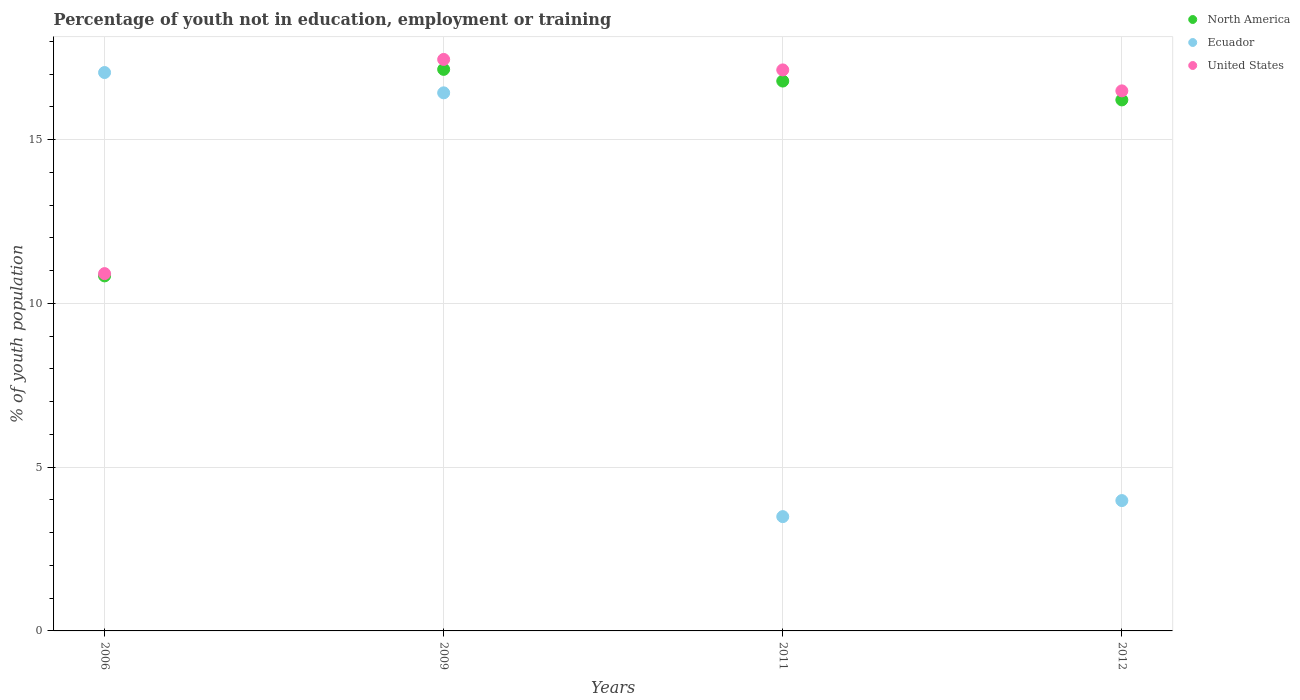Is the number of dotlines equal to the number of legend labels?
Your response must be concise. Yes. What is the percentage of unemployed youth population in in Ecuador in 2011?
Ensure brevity in your answer.  3.49. Across all years, what is the maximum percentage of unemployed youth population in in Ecuador?
Your answer should be compact. 17.05. Across all years, what is the minimum percentage of unemployed youth population in in Ecuador?
Keep it short and to the point. 3.49. In which year was the percentage of unemployed youth population in in Ecuador maximum?
Make the answer very short. 2006. What is the total percentage of unemployed youth population in in North America in the graph?
Provide a succinct answer. 60.99. What is the difference between the percentage of unemployed youth population in in North America in 2011 and that in 2012?
Provide a short and direct response. 0.58. What is the difference between the percentage of unemployed youth population in in United States in 2011 and the percentage of unemployed youth population in in North America in 2012?
Offer a terse response. 0.92. What is the average percentage of unemployed youth population in in Ecuador per year?
Provide a succinct answer. 10.24. In the year 2009, what is the difference between the percentage of unemployed youth population in in Ecuador and percentage of unemployed youth population in in United States?
Your response must be concise. -1.02. In how many years, is the percentage of unemployed youth population in in United States greater than 16 %?
Provide a succinct answer. 3. What is the ratio of the percentage of unemployed youth population in in United States in 2006 to that in 2009?
Your response must be concise. 0.63. Is the percentage of unemployed youth population in in Ecuador in 2006 less than that in 2009?
Your answer should be compact. No. What is the difference between the highest and the second highest percentage of unemployed youth population in in United States?
Provide a short and direct response. 0.32. What is the difference between the highest and the lowest percentage of unemployed youth population in in North America?
Give a very brief answer. 6.31. Is the sum of the percentage of unemployed youth population in in United States in 2009 and 2012 greater than the maximum percentage of unemployed youth population in in North America across all years?
Make the answer very short. Yes. Is it the case that in every year, the sum of the percentage of unemployed youth population in in North America and percentage of unemployed youth population in in United States  is greater than the percentage of unemployed youth population in in Ecuador?
Ensure brevity in your answer.  Yes. Does the percentage of unemployed youth population in in United States monotonically increase over the years?
Provide a short and direct response. No. Is the percentage of unemployed youth population in in United States strictly greater than the percentage of unemployed youth population in in Ecuador over the years?
Ensure brevity in your answer.  No. Is the percentage of unemployed youth population in in Ecuador strictly less than the percentage of unemployed youth population in in United States over the years?
Give a very brief answer. No. How many years are there in the graph?
Your answer should be compact. 4. What is the difference between two consecutive major ticks on the Y-axis?
Offer a very short reply. 5. Does the graph contain grids?
Give a very brief answer. Yes. Where does the legend appear in the graph?
Offer a very short reply. Top right. How many legend labels are there?
Make the answer very short. 3. How are the legend labels stacked?
Make the answer very short. Vertical. What is the title of the graph?
Your answer should be compact. Percentage of youth not in education, employment or training. Does "Luxembourg" appear as one of the legend labels in the graph?
Give a very brief answer. No. What is the label or title of the X-axis?
Offer a very short reply. Years. What is the label or title of the Y-axis?
Make the answer very short. % of youth population. What is the % of youth population in North America in 2006?
Provide a short and direct response. 10.84. What is the % of youth population of Ecuador in 2006?
Keep it short and to the point. 17.05. What is the % of youth population of United States in 2006?
Provide a short and direct response. 10.91. What is the % of youth population in North America in 2009?
Your answer should be very brief. 17.15. What is the % of youth population of Ecuador in 2009?
Your answer should be compact. 16.43. What is the % of youth population of United States in 2009?
Your answer should be very brief. 17.45. What is the % of youth population of North America in 2011?
Offer a very short reply. 16.79. What is the % of youth population of Ecuador in 2011?
Give a very brief answer. 3.49. What is the % of youth population in United States in 2011?
Give a very brief answer. 17.13. What is the % of youth population of North America in 2012?
Ensure brevity in your answer.  16.21. What is the % of youth population in Ecuador in 2012?
Provide a short and direct response. 3.98. What is the % of youth population of United States in 2012?
Your response must be concise. 16.49. Across all years, what is the maximum % of youth population of North America?
Your answer should be very brief. 17.15. Across all years, what is the maximum % of youth population in Ecuador?
Provide a succinct answer. 17.05. Across all years, what is the maximum % of youth population in United States?
Make the answer very short. 17.45. Across all years, what is the minimum % of youth population of North America?
Make the answer very short. 10.84. Across all years, what is the minimum % of youth population of Ecuador?
Make the answer very short. 3.49. Across all years, what is the minimum % of youth population of United States?
Give a very brief answer. 10.91. What is the total % of youth population in North America in the graph?
Offer a very short reply. 60.99. What is the total % of youth population of Ecuador in the graph?
Your answer should be very brief. 40.95. What is the total % of youth population in United States in the graph?
Your answer should be very brief. 61.98. What is the difference between the % of youth population in North America in 2006 and that in 2009?
Your response must be concise. -6.31. What is the difference between the % of youth population of Ecuador in 2006 and that in 2009?
Your answer should be very brief. 0.62. What is the difference between the % of youth population in United States in 2006 and that in 2009?
Ensure brevity in your answer.  -6.54. What is the difference between the % of youth population of North America in 2006 and that in 2011?
Your response must be concise. -5.95. What is the difference between the % of youth population in Ecuador in 2006 and that in 2011?
Keep it short and to the point. 13.56. What is the difference between the % of youth population in United States in 2006 and that in 2011?
Ensure brevity in your answer.  -6.22. What is the difference between the % of youth population in North America in 2006 and that in 2012?
Offer a very short reply. -5.37. What is the difference between the % of youth population in Ecuador in 2006 and that in 2012?
Your answer should be compact. 13.07. What is the difference between the % of youth population of United States in 2006 and that in 2012?
Keep it short and to the point. -5.58. What is the difference between the % of youth population in North America in 2009 and that in 2011?
Your answer should be very brief. 0.36. What is the difference between the % of youth population in Ecuador in 2009 and that in 2011?
Keep it short and to the point. 12.94. What is the difference between the % of youth population in United States in 2009 and that in 2011?
Give a very brief answer. 0.32. What is the difference between the % of youth population in North America in 2009 and that in 2012?
Offer a very short reply. 0.93. What is the difference between the % of youth population in Ecuador in 2009 and that in 2012?
Keep it short and to the point. 12.45. What is the difference between the % of youth population of North America in 2011 and that in 2012?
Your answer should be compact. 0.58. What is the difference between the % of youth population of Ecuador in 2011 and that in 2012?
Make the answer very short. -0.49. What is the difference between the % of youth population in United States in 2011 and that in 2012?
Your answer should be compact. 0.64. What is the difference between the % of youth population in North America in 2006 and the % of youth population in Ecuador in 2009?
Offer a very short reply. -5.59. What is the difference between the % of youth population of North America in 2006 and the % of youth population of United States in 2009?
Offer a very short reply. -6.61. What is the difference between the % of youth population of North America in 2006 and the % of youth population of Ecuador in 2011?
Make the answer very short. 7.35. What is the difference between the % of youth population in North America in 2006 and the % of youth population in United States in 2011?
Offer a terse response. -6.29. What is the difference between the % of youth population of Ecuador in 2006 and the % of youth population of United States in 2011?
Offer a terse response. -0.08. What is the difference between the % of youth population in North America in 2006 and the % of youth population in Ecuador in 2012?
Provide a short and direct response. 6.86. What is the difference between the % of youth population in North America in 2006 and the % of youth population in United States in 2012?
Make the answer very short. -5.65. What is the difference between the % of youth population of Ecuador in 2006 and the % of youth population of United States in 2012?
Give a very brief answer. 0.56. What is the difference between the % of youth population in North America in 2009 and the % of youth population in Ecuador in 2011?
Your response must be concise. 13.66. What is the difference between the % of youth population in North America in 2009 and the % of youth population in United States in 2011?
Ensure brevity in your answer.  0.02. What is the difference between the % of youth population in Ecuador in 2009 and the % of youth population in United States in 2011?
Give a very brief answer. -0.7. What is the difference between the % of youth population of North America in 2009 and the % of youth population of Ecuador in 2012?
Keep it short and to the point. 13.17. What is the difference between the % of youth population of North America in 2009 and the % of youth population of United States in 2012?
Provide a short and direct response. 0.66. What is the difference between the % of youth population of Ecuador in 2009 and the % of youth population of United States in 2012?
Make the answer very short. -0.06. What is the difference between the % of youth population in North America in 2011 and the % of youth population in Ecuador in 2012?
Your answer should be very brief. 12.81. What is the difference between the % of youth population of North America in 2011 and the % of youth population of United States in 2012?
Provide a short and direct response. 0.3. What is the average % of youth population in North America per year?
Your response must be concise. 15.25. What is the average % of youth population in Ecuador per year?
Offer a terse response. 10.24. What is the average % of youth population in United States per year?
Your answer should be compact. 15.49. In the year 2006, what is the difference between the % of youth population of North America and % of youth population of Ecuador?
Ensure brevity in your answer.  -6.21. In the year 2006, what is the difference between the % of youth population in North America and % of youth population in United States?
Your response must be concise. -0.07. In the year 2006, what is the difference between the % of youth population in Ecuador and % of youth population in United States?
Your answer should be compact. 6.14. In the year 2009, what is the difference between the % of youth population of North America and % of youth population of Ecuador?
Ensure brevity in your answer.  0.72. In the year 2009, what is the difference between the % of youth population in North America and % of youth population in United States?
Offer a terse response. -0.3. In the year 2009, what is the difference between the % of youth population in Ecuador and % of youth population in United States?
Your answer should be compact. -1.02. In the year 2011, what is the difference between the % of youth population of North America and % of youth population of Ecuador?
Give a very brief answer. 13.3. In the year 2011, what is the difference between the % of youth population in North America and % of youth population in United States?
Offer a terse response. -0.34. In the year 2011, what is the difference between the % of youth population of Ecuador and % of youth population of United States?
Give a very brief answer. -13.64. In the year 2012, what is the difference between the % of youth population in North America and % of youth population in Ecuador?
Provide a succinct answer. 12.23. In the year 2012, what is the difference between the % of youth population of North America and % of youth population of United States?
Ensure brevity in your answer.  -0.28. In the year 2012, what is the difference between the % of youth population in Ecuador and % of youth population in United States?
Give a very brief answer. -12.51. What is the ratio of the % of youth population in North America in 2006 to that in 2009?
Make the answer very short. 0.63. What is the ratio of the % of youth population of Ecuador in 2006 to that in 2009?
Ensure brevity in your answer.  1.04. What is the ratio of the % of youth population in United States in 2006 to that in 2009?
Keep it short and to the point. 0.63. What is the ratio of the % of youth population of North America in 2006 to that in 2011?
Ensure brevity in your answer.  0.65. What is the ratio of the % of youth population of Ecuador in 2006 to that in 2011?
Keep it short and to the point. 4.89. What is the ratio of the % of youth population of United States in 2006 to that in 2011?
Keep it short and to the point. 0.64. What is the ratio of the % of youth population in North America in 2006 to that in 2012?
Your response must be concise. 0.67. What is the ratio of the % of youth population in Ecuador in 2006 to that in 2012?
Provide a succinct answer. 4.28. What is the ratio of the % of youth population of United States in 2006 to that in 2012?
Offer a very short reply. 0.66. What is the ratio of the % of youth population of North America in 2009 to that in 2011?
Offer a very short reply. 1.02. What is the ratio of the % of youth population in Ecuador in 2009 to that in 2011?
Give a very brief answer. 4.71. What is the ratio of the % of youth population in United States in 2009 to that in 2011?
Your response must be concise. 1.02. What is the ratio of the % of youth population of North America in 2009 to that in 2012?
Provide a short and direct response. 1.06. What is the ratio of the % of youth population of Ecuador in 2009 to that in 2012?
Keep it short and to the point. 4.13. What is the ratio of the % of youth population in United States in 2009 to that in 2012?
Offer a very short reply. 1.06. What is the ratio of the % of youth population of North America in 2011 to that in 2012?
Give a very brief answer. 1.04. What is the ratio of the % of youth population in Ecuador in 2011 to that in 2012?
Your answer should be compact. 0.88. What is the ratio of the % of youth population in United States in 2011 to that in 2012?
Make the answer very short. 1.04. What is the difference between the highest and the second highest % of youth population of North America?
Keep it short and to the point. 0.36. What is the difference between the highest and the second highest % of youth population of Ecuador?
Your response must be concise. 0.62. What is the difference between the highest and the second highest % of youth population in United States?
Offer a very short reply. 0.32. What is the difference between the highest and the lowest % of youth population in North America?
Ensure brevity in your answer.  6.31. What is the difference between the highest and the lowest % of youth population in Ecuador?
Give a very brief answer. 13.56. What is the difference between the highest and the lowest % of youth population in United States?
Provide a short and direct response. 6.54. 